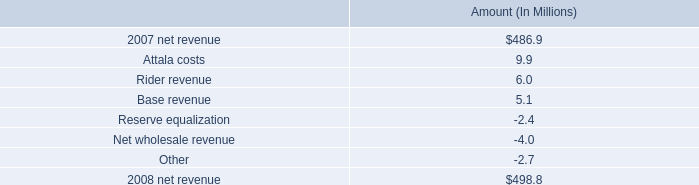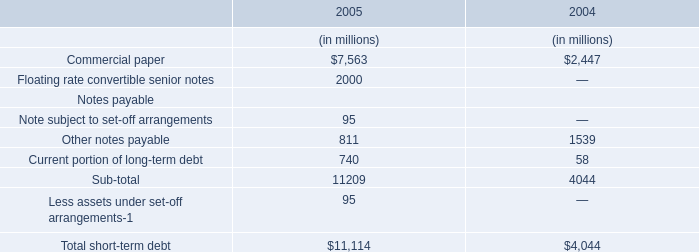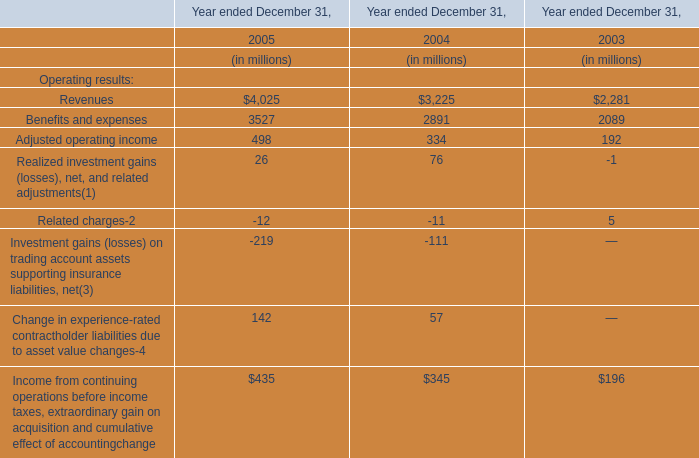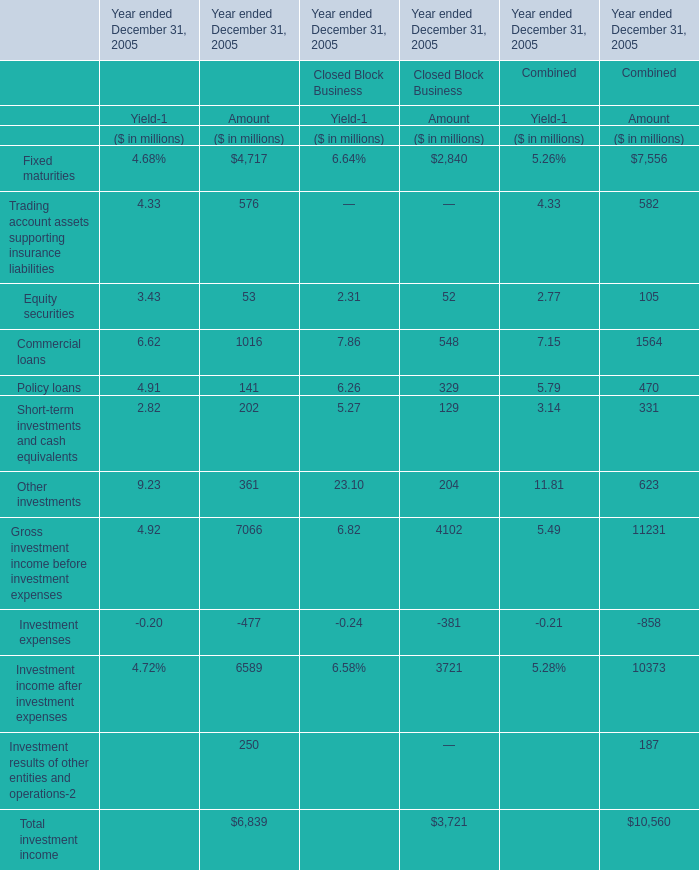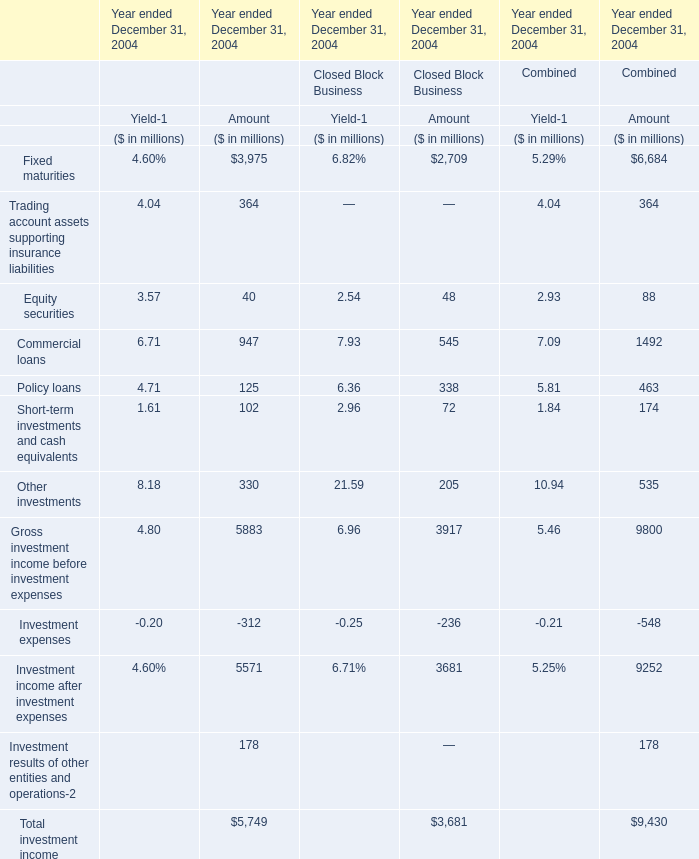Which section is Fixed maturities the highest for amount ? 
Answer: Financial Services Businesses. 